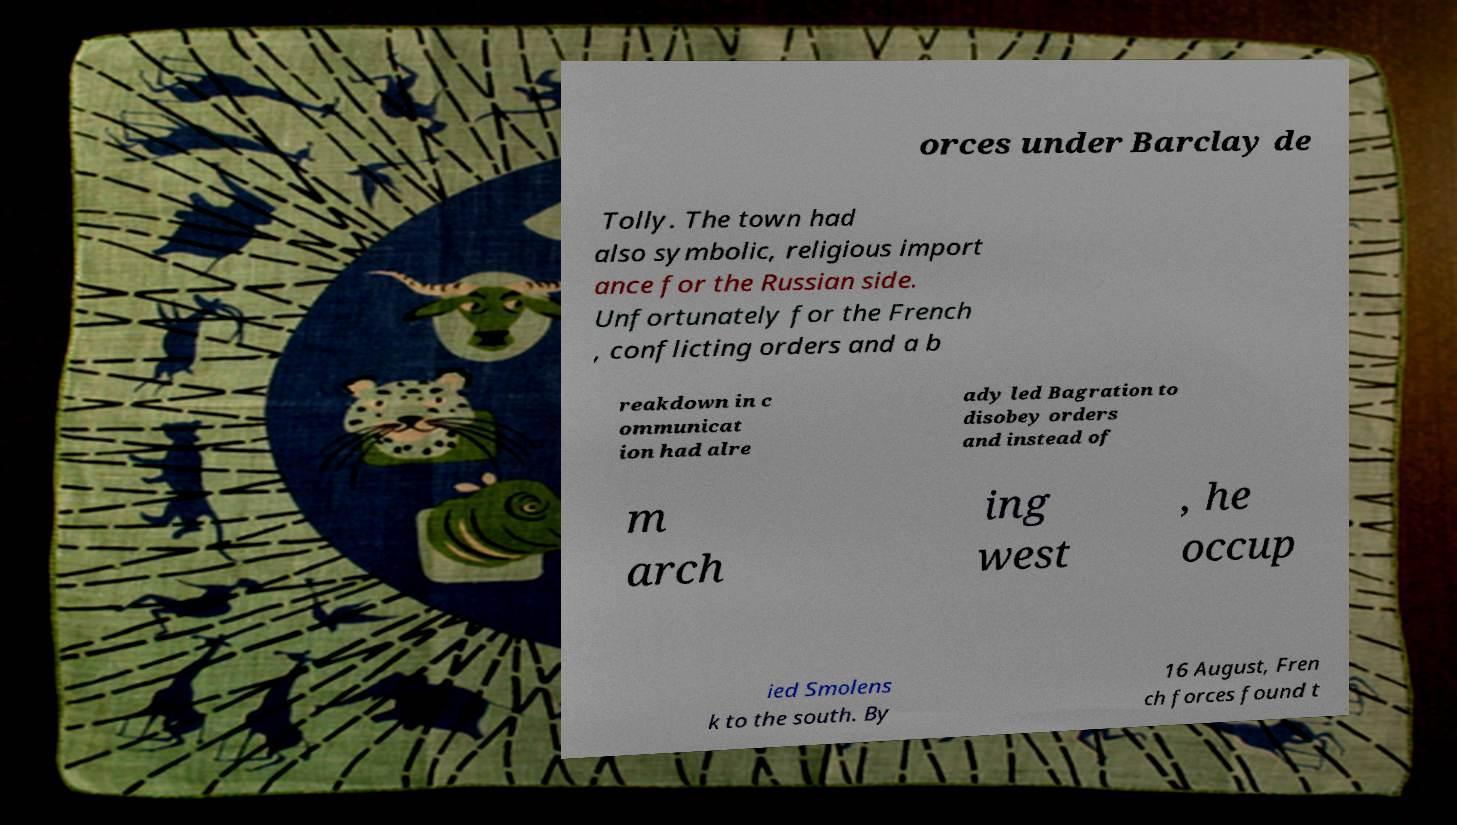Could you assist in decoding the text presented in this image and type it out clearly? orces under Barclay de Tolly. The town had also symbolic, religious import ance for the Russian side. Unfortunately for the French , conflicting orders and a b reakdown in c ommunicat ion had alre ady led Bagration to disobey orders and instead of m arch ing west , he occup ied Smolens k to the south. By 16 August, Fren ch forces found t 